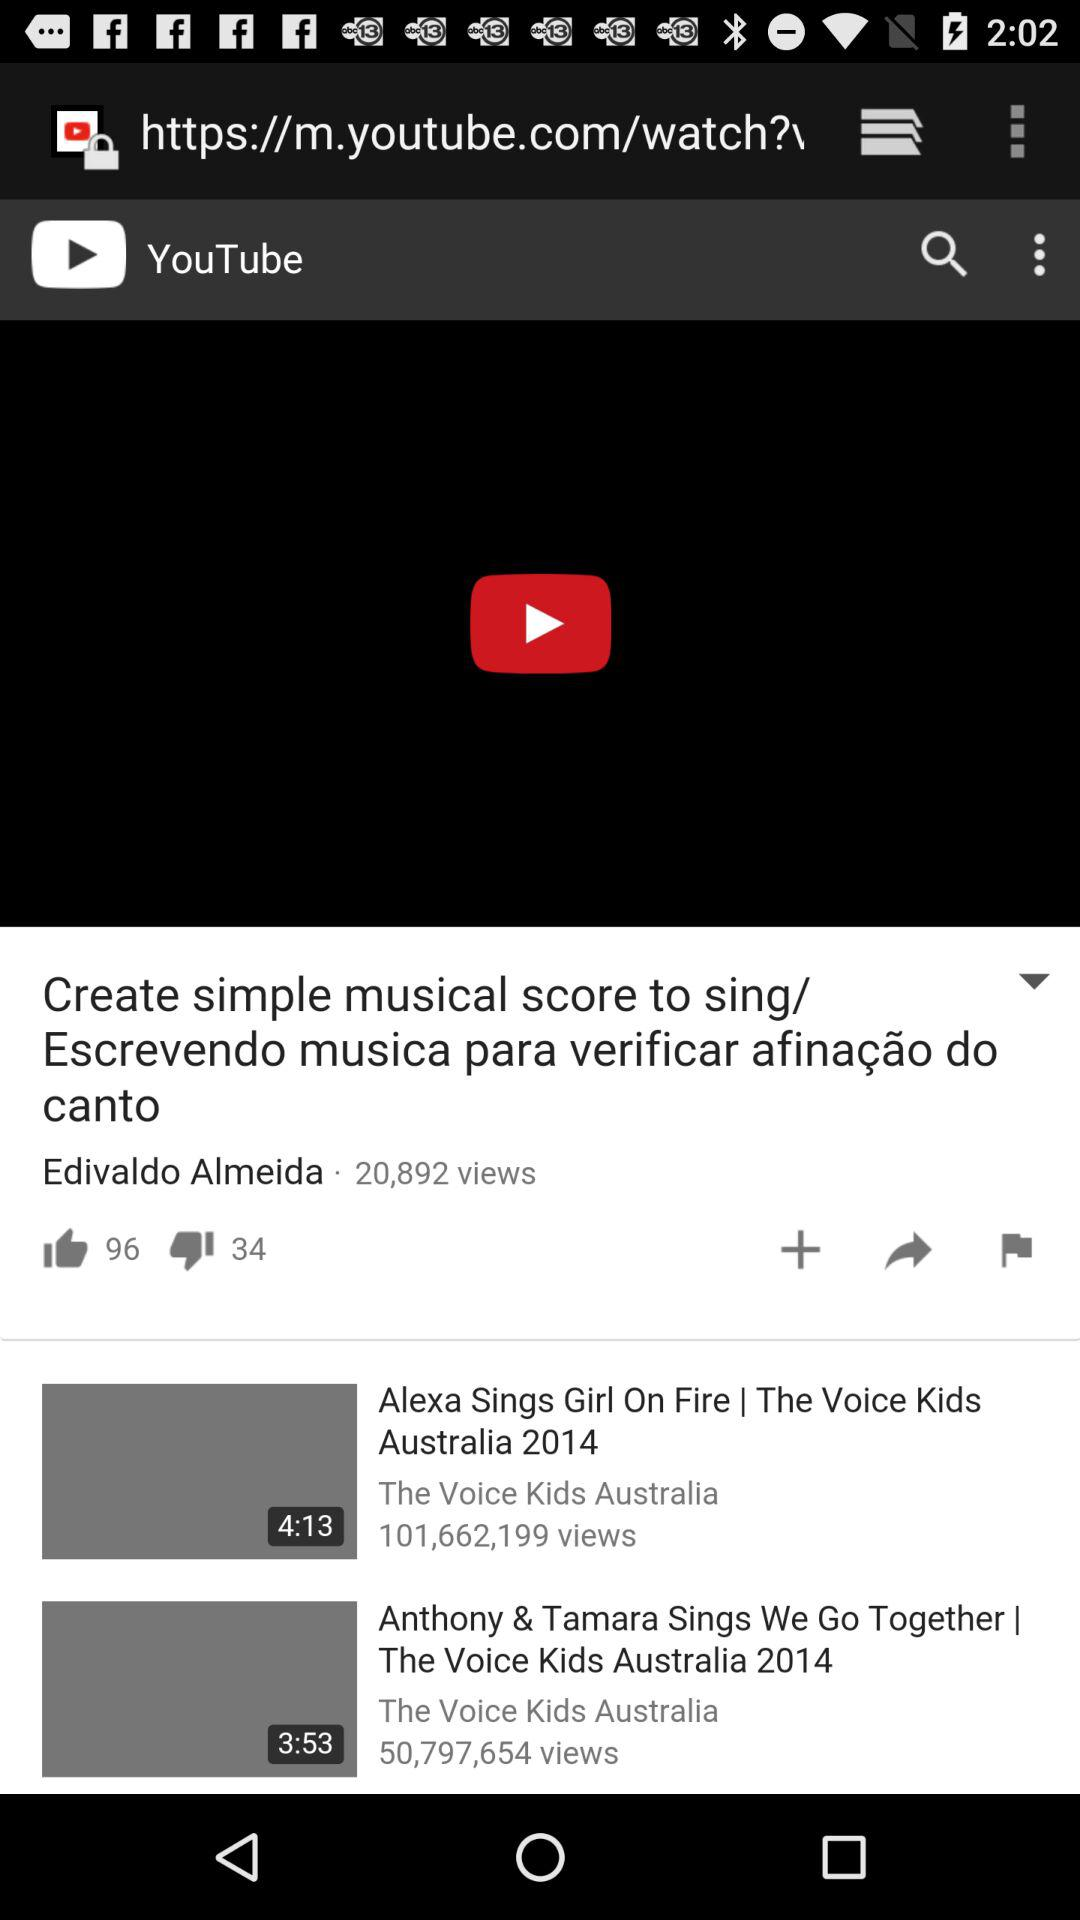What is the title of the video shown at the top of the screen? The title of the video is "Create simple musical score to sing/ Escrevendo musica para verificar afinação do canto". 